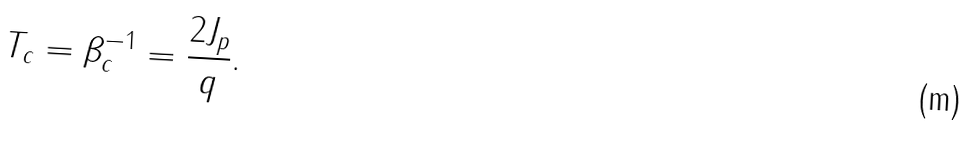Convert formula to latex. <formula><loc_0><loc_0><loc_500><loc_500>T _ { c } = \beta ^ { - 1 } _ { c } = \frac { 2 J _ { p } } { q } .</formula> 